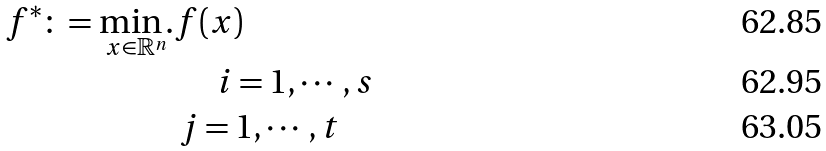Convert formula to latex. <formula><loc_0><loc_0><loc_500><loc_500>f ^ { * } \colon = \underset { x \in \mathbb { R } ^ { n } } { \min . } & f ( x ) \\ & \, \quad \, i = 1 , \cdots , s \\ & \, j = 1 , \cdots , t</formula> 